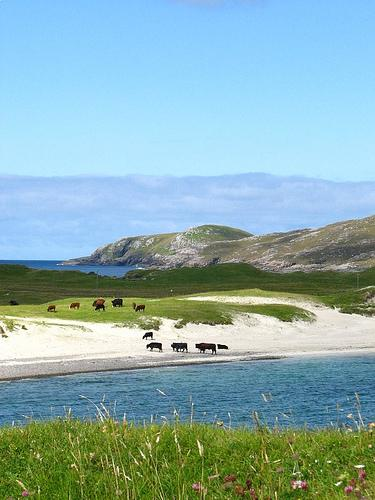How would they transport the cattle to the nearest patch of grass?

Choices:
A) rope
B) boat
C) buoys
D) swim boat 